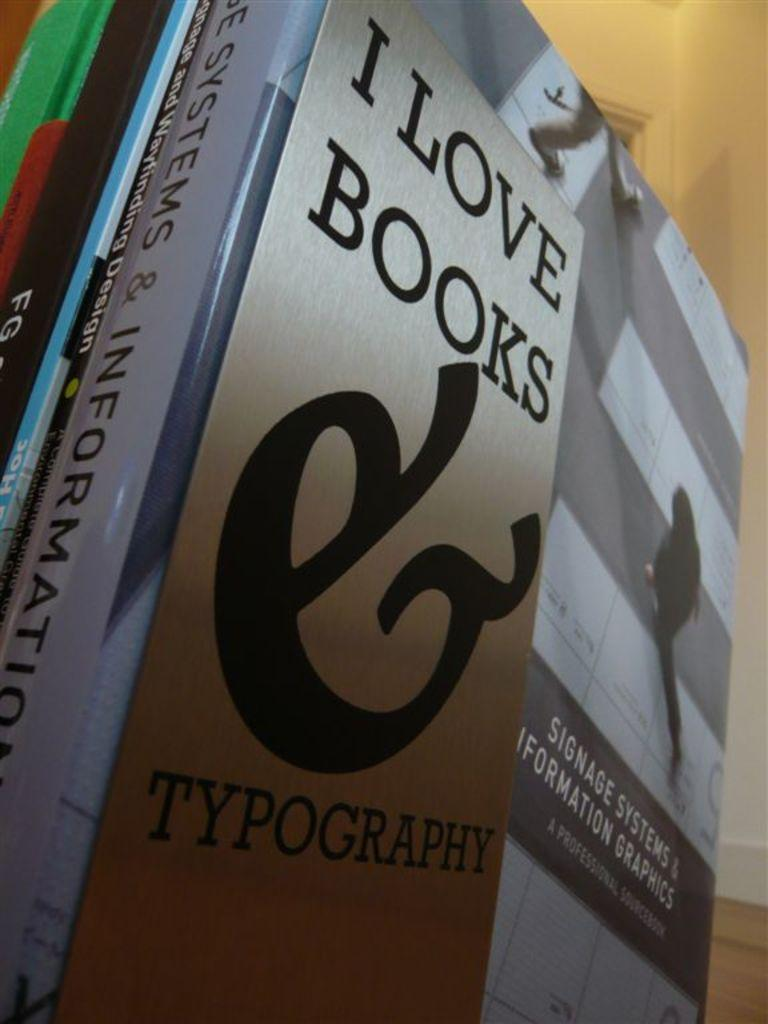Provide a one-sentence caption for the provided image. I love books typography book in a room on the floor. 